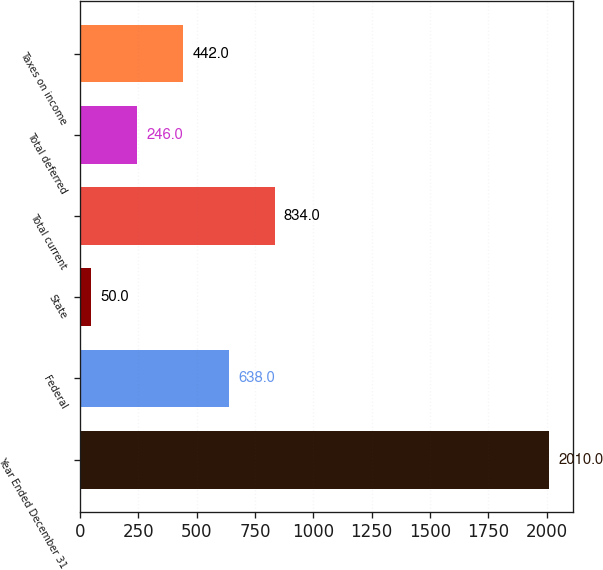Convert chart. <chart><loc_0><loc_0><loc_500><loc_500><bar_chart><fcel>Year Ended December 31<fcel>Federal<fcel>State<fcel>Total current<fcel>Total deferred<fcel>Taxes on income<nl><fcel>2010<fcel>638<fcel>50<fcel>834<fcel>246<fcel>442<nl></chart> 